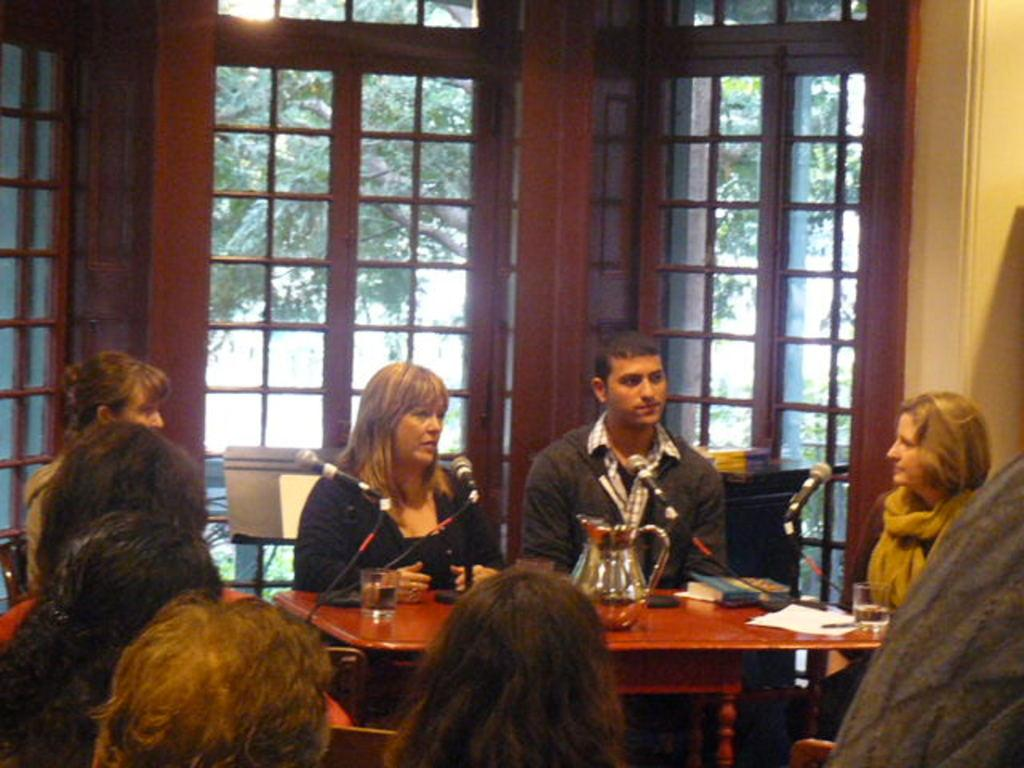What is happening in the center of the image? There are people in the center of the image. What are the people doing in the image? The people are sitting around a table. What objects can be seen on the table? There are glasses, books, and microphones on the table. What architectural feature is visible in the center of the image? There are windows in the center of the image. Is there any blood visible on the table in the image? No, there is no blood visible on the table in the image. Who is the father of the person sitting at the table in the image? The provided facts do not give any information about the relationships between the people in the image, so it is impossible to determine the father of any person at the table. 